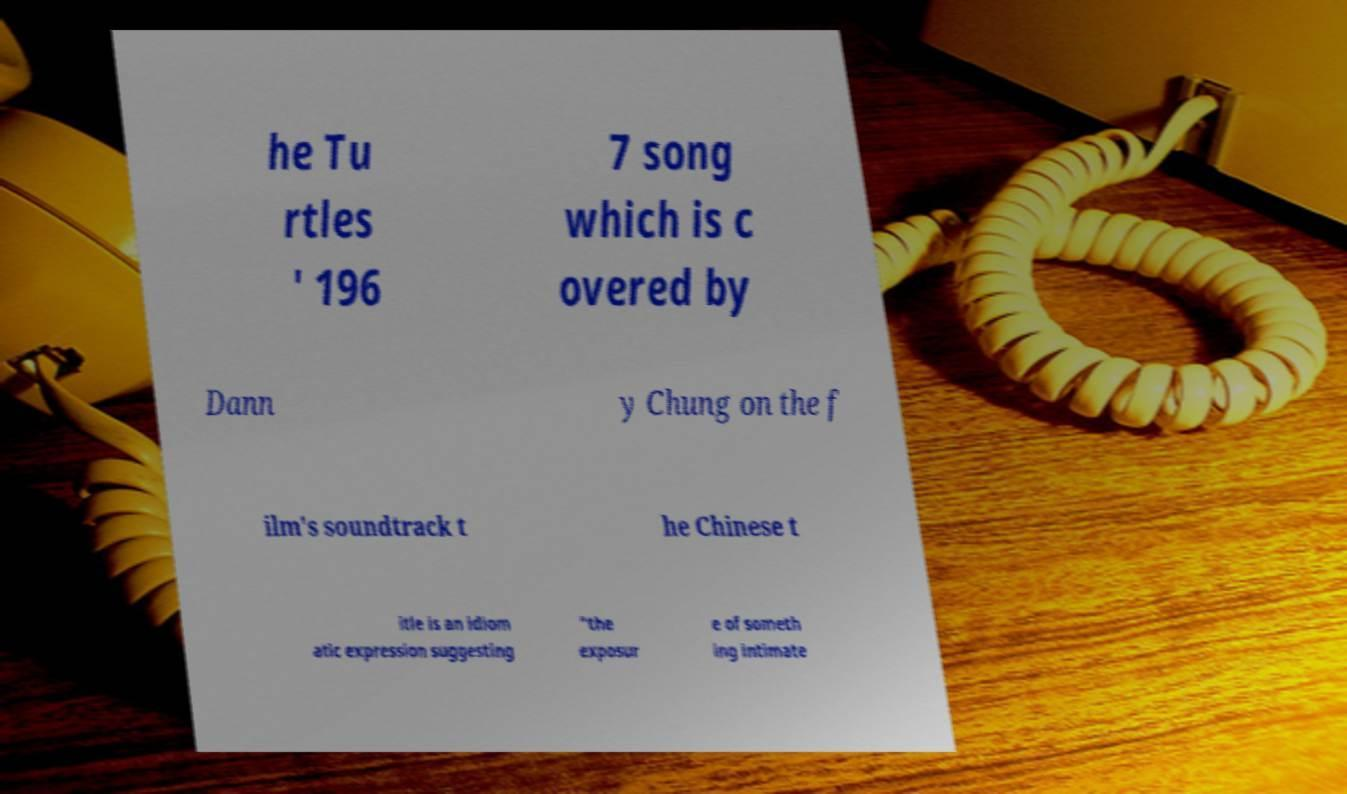Can you accurately transcribe the text from the provided image for me? he Tu rtles ' 196 7 song which is c overed by Dann y Chung on the f ilm's soundtrack t he Chinese t itle is an idiom atic expression suggesting "the exposur e of someth ing intimate 